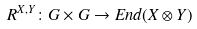<formula> <loc_0><loc_0><loc_500><loc_500>R ^ { X , Y } \colon G \times G \to E n d ( X \otimes Y )</formula> 